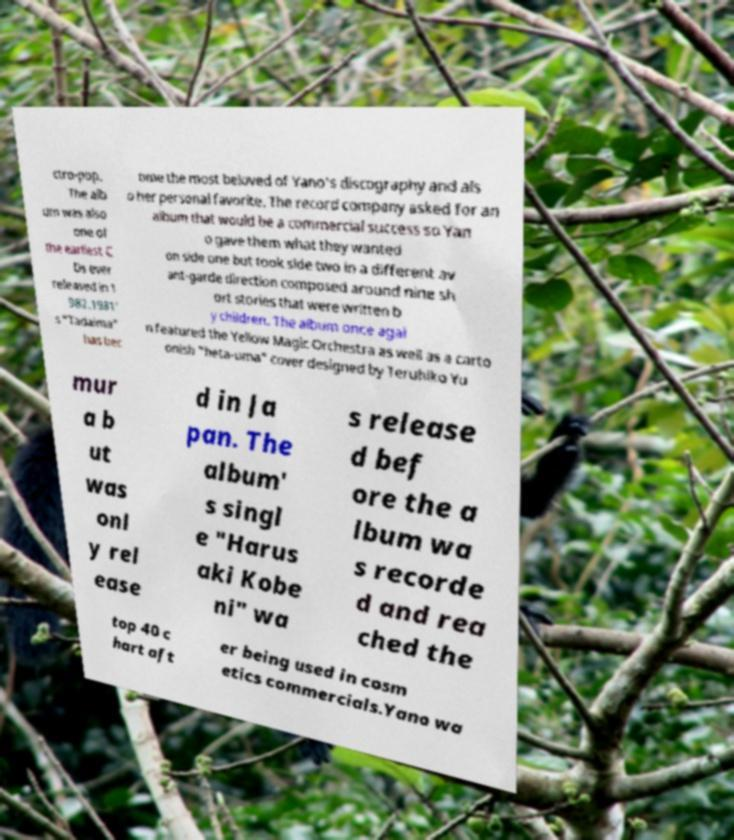What messages or text are displayed in this image? I need them in a readable, typed format. ctro-pop. The alb um was also one of the earliest C Ds ever released in 1 982.1981' s "Tadaima" has bec ome the most beloved of Yano's discography and als o her personal favorite. The record company asked for an album that would be a commercial success so Yan o gave them what they wanted on side one but took side two in a different av ant-garde direction composed around nine sh ort stories that were written b y children. The album once agai n featured the Yellow Magic Orchestra as well as a carto onish "heta-uma" cover designed by Teruhiko Yu mur a b ut was onl y rel ease d in Ja pan. The album' s singl e "Harus aki Kobe ni" wa s release d bef ore the a lbum wa s recorde d and rea ched the top 40 c hart aft er being used in cosm etics commercials.Yano wa 